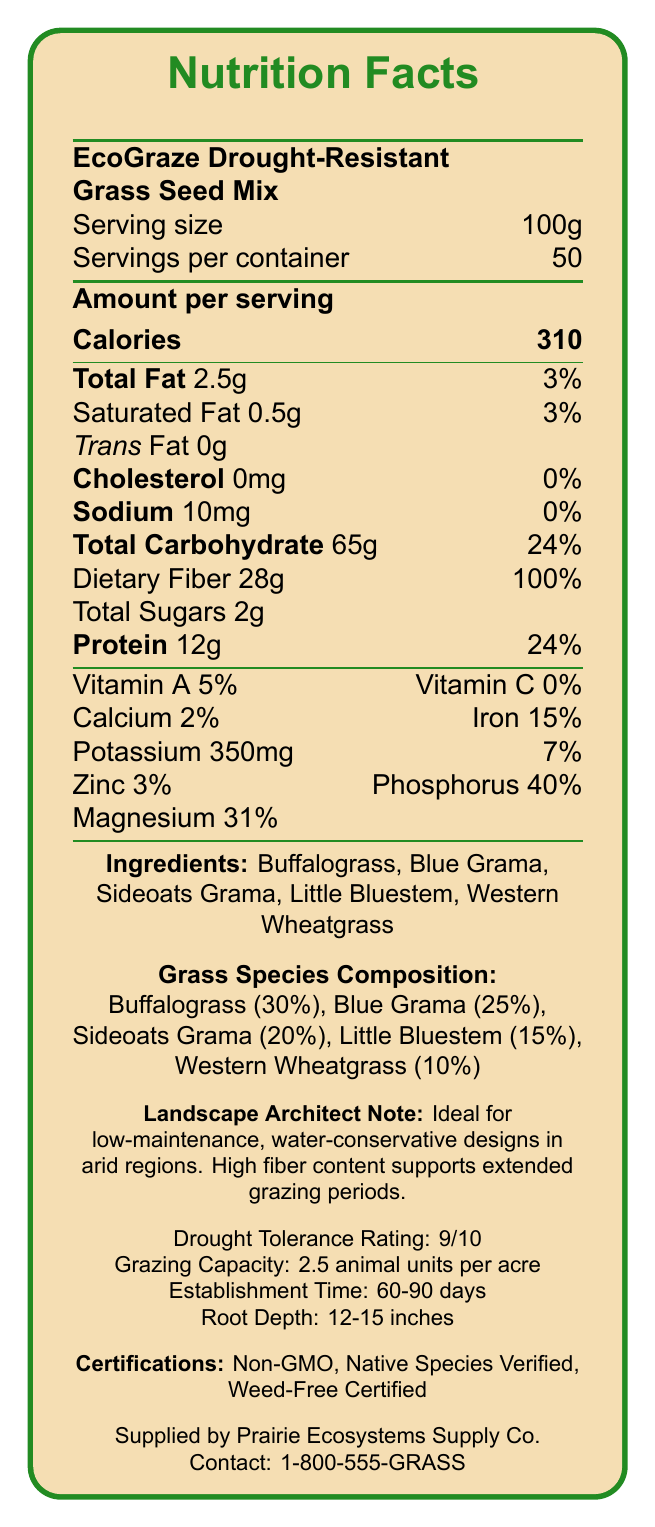who is the supplier of the grass seed mix? The supplier information is listed at the bottom of the document.
Answer: Prairie Ecosystems Supply Co. what is the serving size of EcoGraze Drought-Resistant Grass Seed Mix? The serving size is clearly mentioned at the top of the Nutrition Facts Label.
Answer: 100g how many servings are there per container? This information is listed under the serving size at the top of the document.
Answer: 50 what is the total carbohydrate content per serving? The total carbohydrate content is listed under the "Amount per serving" section.
Answer: 65g what is the drought tolerance rating of this grass seed mix? This information is provided towards the bottom where additional product features are listed.
Answer: 9/10 which of the following ingredients is present in the highest percentage? A. Blue Grama B. Sideoats Grama C. Buffalograss The document lists Buffalograss as the ingredient with the highest percentage (30%) under "Grass Species Composition".
Answer: C. Buffalograss how much dietary fiber is in a serving? The dietary fiber content is listed under the Nutritional Facts section.
Answer: 28g what is the root depth range for the EcoGraze grass? The root depth is mentioned in the product features section towards the bottom of the document.
Answer: 12-15 inches is the EcoGraze grass seed mix GMO-free? The document lists "Non-GMO" under certifications.
Answer: Yes what is the main idea of this document? The document includes detailed Nutritional Facts, ingredient composition, drought tolerance, grazing capacity, certifications, and supplier contact information.
Answer: The document provides nutritional information, ingredient composition, and additional product features for the EcoGraze Drought-Resistant Grass Seed Mix, which is designed for low-maintenance, water-conservative landscapes. what is the specific establishment time for the grass seed mix? The establishment time is mentioned in the product features section at the bottom of the document.
Answer: 60-90 days does the grass seed mix include any trans fat? The document lists the trans fat content as 0g under the Nutritional Facts section.
Answer: No how many calories are there in a serving of EcoGraze Drought-Resistant Grass Seed Mix? The calorie count is listed under the "Amount per serving" section.
Answer: 310 which nutrient has the highest percentage daily value per serving? A. Dietary Fiber B. Protein C. Total Carbohydrate Dietary fiber has a daily value percentage of 100%, which is the highest among the listed nutrients.
Answer: A. Dietary Fiber what is the phosphorus content per serving? This element is listed under the nutrient section as Phosphorus with a value of 280 mg.
Answer: 280 mg how much protein does this mix provide per serving? The protein content is listed under the "Amount per serving" section.
Answer: 12g what is the phone number for the supplier? The supplier contact information is given at the bottom of the document.
Answer: 1-800-555-GRASS what is the percentage of blue grama in the seed mix? The document lists Blue Grama as comprising 25% of the grass species composition.
Answer: 25% what is the annual rainfall requirement for this grass seed mix? The document lists the annual rainfall requirement towards the bottom as being between 12-25 inches.
Answer: 12-25 inches which vitamin is present in the highest amount per serving? A. Vitamin A B. Vitamin C C. Vitamin D Vitamin A has a daily value percentage of 5%, higher than Vitamin C (0%).
Answer: A. Vitamin A what is the protein content per container? While the protein content per serving is provided (12g), the total protein content per container is not directly listed in the document.
Answer: Cannot be determined 